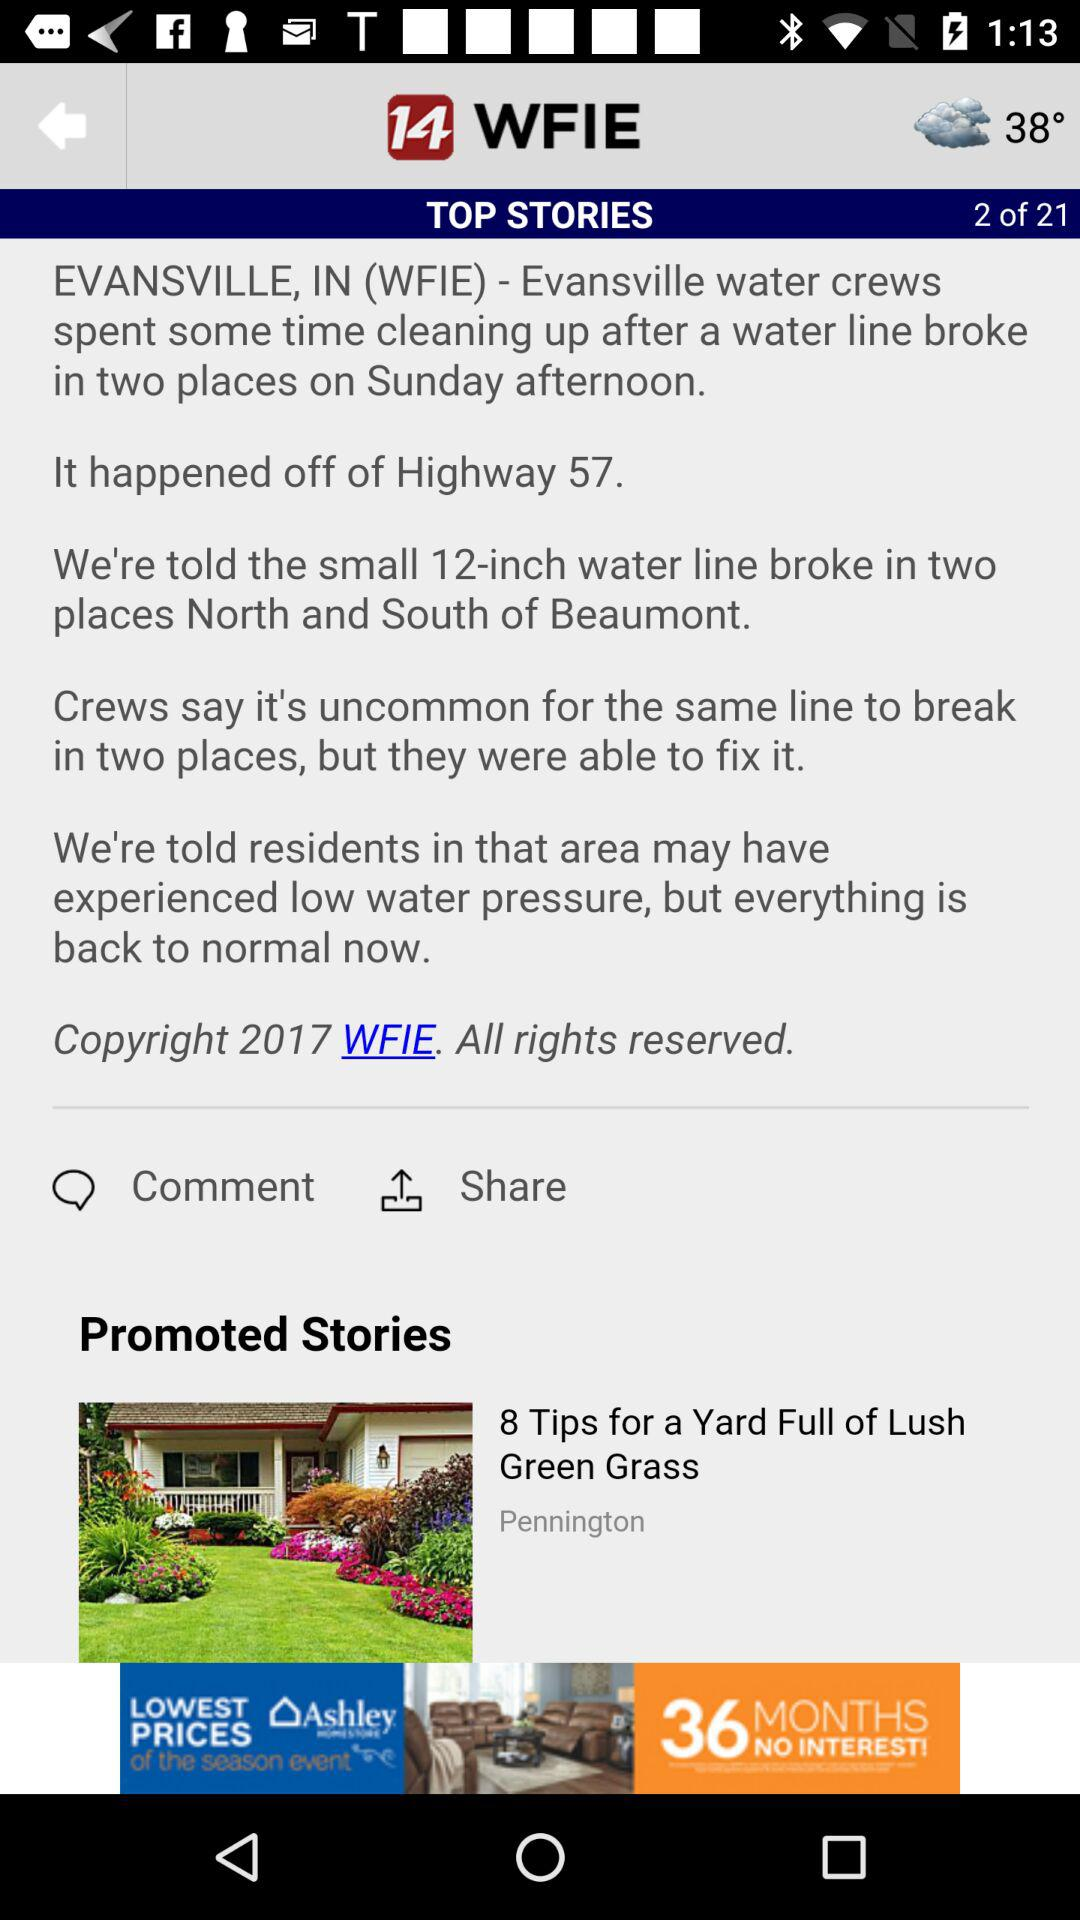Which top story are we at right now? You are at top story number 2. 